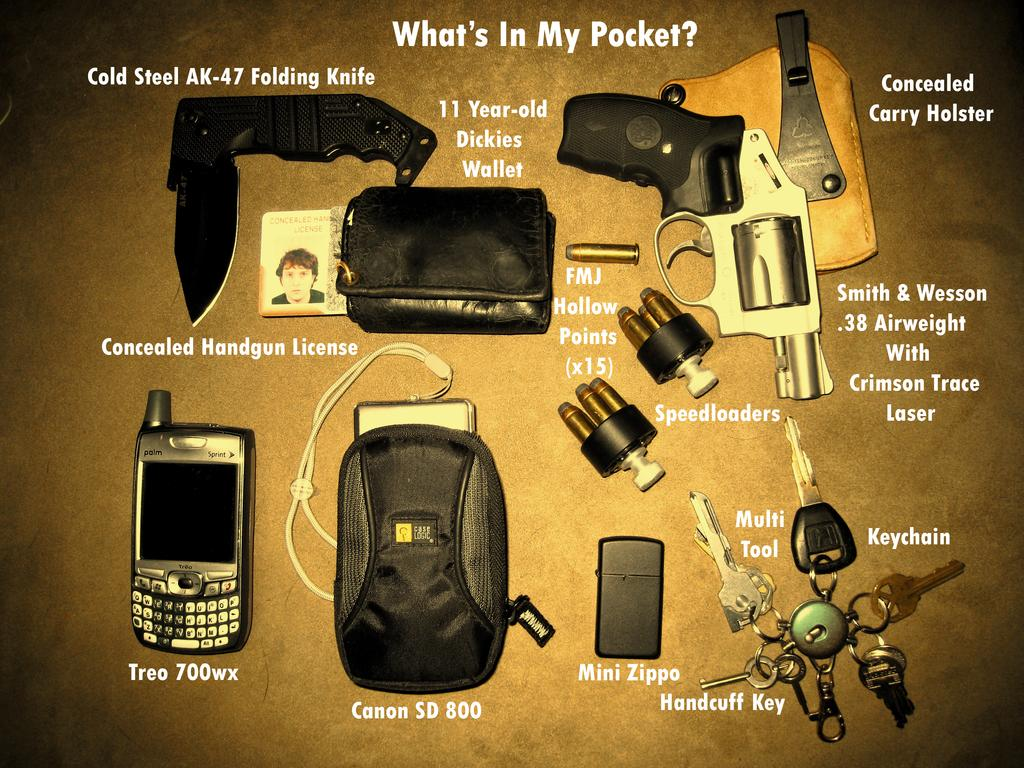<image>
Summarize the visual content of the image. A collection of things are shown, including a Concealed Handgun License, Mini Zippo, and Canon SD 800. 